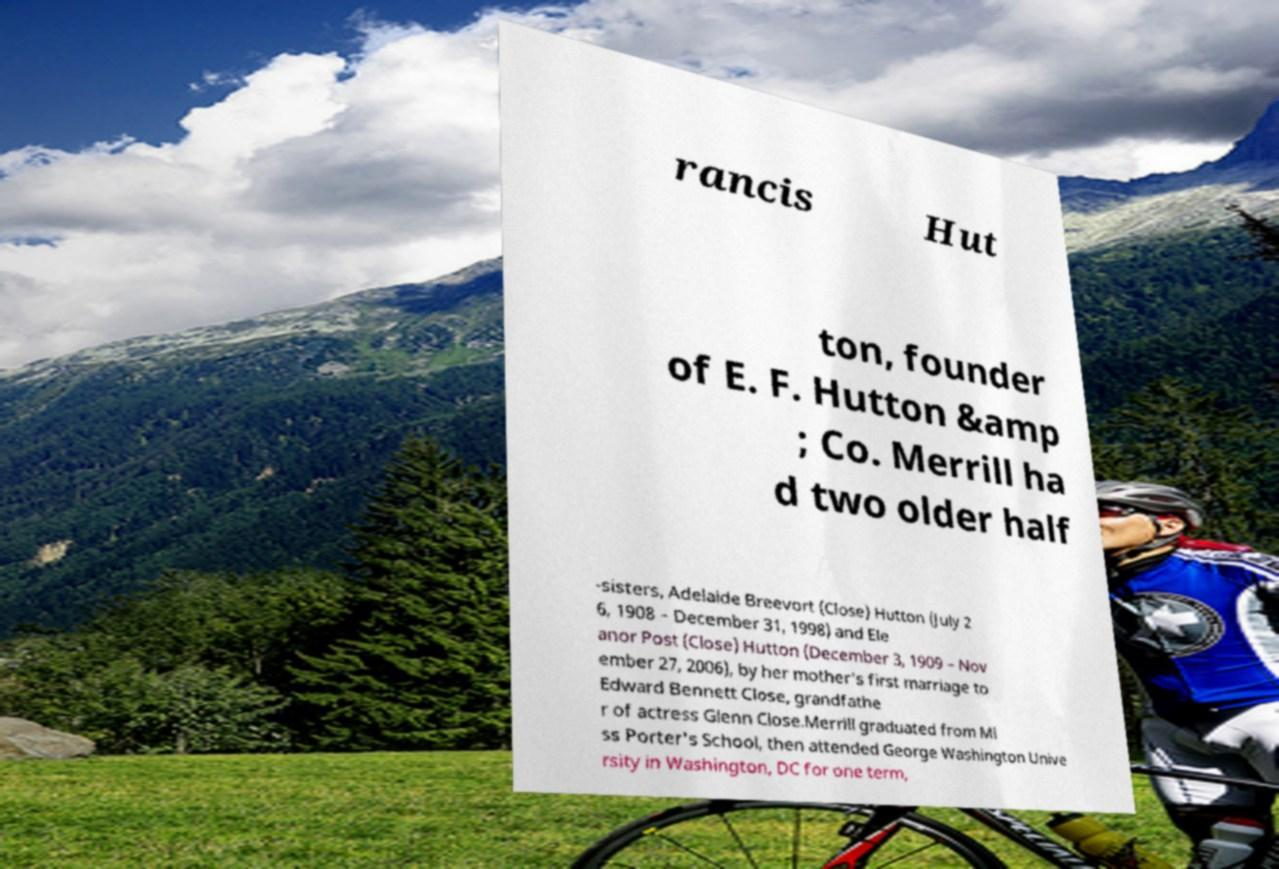For documentation purposes, I need the text within this image transcribed. Could you provide that? rancis Hut ton, founder of E. F. Hutton &amp ; Co. Merrill ha d two older half -sisters, Adelaide Breevort (Close) Hutton (July 2 6, 1908 – December 31, 1998) and Ele anor Post (Close) Hutton (December 3, 1909 – Nov ember 27, 2006), by her mother's first marriage to Edward Bennett Close, grandfathe r of actress Glenn Close.Merrill graduated from Mi ss Porter's School, then attended George Washington Unive rsity in Washington, DC for one term, 